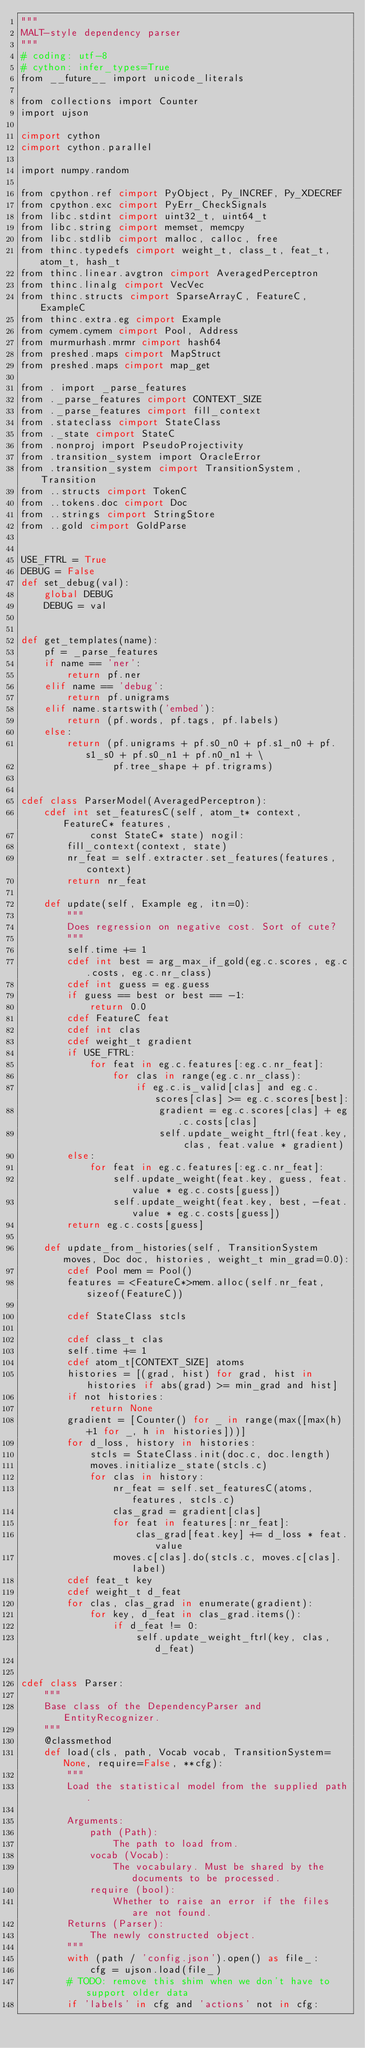<code> <loc_0><loc_0><loc_500><loc_500><_Cython_>"""
MALT-style dependency parser
"""
# coding: utf-8
# cython: infer_types=True
from __future__ import unicode_literals

from collections import Counter
import ujson

cimport cython
cimport cython.parallel

import numpy.random

from cpython.ref cimport PyObject, Py_INCREF, Py_XDECREF
from cpython.exc cimport PyErr_CheckSignals
from libc.stdint cimport uint32_t, uint64_t
from libc.string cimport memset, memcpy
from libc.stdlib cimport malloc, calloc, free
from thinc.typedefs cimport weight_t, class_t, feat_t, atom_t, hash_t
from thinc.linear.avgtron cimport AveragedPerceptron
from thinc.linalg cimport VecVec
from thinc.structs cimport SparseArrayC, FeatureC, ExampleC
from thinc.extra.eg cimport Example
from cymem.cymem cimport Pool, Address
from murmurhash.mrmr cimport hash64
from preshed.maps cimport MapStruct
from preshed.maps cimport map_get

from . import _parse_features
from ._parse_features cimport CONTEXT_SIZE
from ._parse_features cimport fill_context
from .stateclass cimport StateClass
from ._state cimport StateC
from .nonproj import PseudoProjectivity
from .transition_system import OracleError
from .transition_system cimport TransitionSystem, Transition
from ..structs cimport TokenC
from ..tokens.doc cimport Doc
from ..strings cimport StringStore
from ..gold cimport GoldParse


USE_FTRL = True
DEBUG = False
def set_debug(val):
    global DEBUG
    DEBUG = val


def get_templates(name):
    pf = _parse_features
    if name == 'ner':
        return pf.ner
    elif name == 'debug':
        return pf.unigrams
    elif name.startswith('embed'):
        return (pf.words, pf.tags, pf.labels)
    else:
        return (pf.unigrams + pf.s0_n0 + pf.s1_n0 + pf.s1_s0 + pf.s0_n1 + pf.n0_n1 + \
                pf.tree_shape + pf.trigrams)


cdef class ParserModel(AveragedPerceptron):
    cdef int set_featuresC(self, atom_t* context, FeatureC* features,
            const StateC* state) nogil:
        fill_context(context, state)
        nr_feat = self.extracter.set_features(features, context)
        return nr_feat

    def update(self, Example eg, itn=0):
        """
        Does regression on negative cost. Sort of cute?
        """
        self.time += 1
        cdef int best = arg_max_if_gold(eg.c.scores, eg.c.costs, eg.c.nr_class)
        cdef int guess = eg.guess
        if guess == best or best == -1:
            return 0.0
        cdef FeatureC feat
        cdef int clas
        cdef weight_t gradient
        if USE_FTRL:
            for feat in eg.c.features[:eg.c.nr_feat]:
                for clas in range(eg.c.nr_class):
                    if eg.c.is_valid[clas] and eg.c.scores[clas] >= eg.c.scores[best]:
                        gradient = eg.c.scores[clas] + eg.c.costs[clas]
                        self.update_weight_ftrl(feat.key, clas, feat.value * gradient)
        else:
            for feat in eg.c.features[:eg.c.nr_feat]:
                self.update_weight(feat.key, guess, feat.value * eg.c.costs[guess])
                self.update_weight(feat.key, best, -feat.value * eg.c.costs[guess])
        return eg.c.costs[guess]

    def update_from_histories(self, TransitionSystem moves, Doc doc, histories, weight_t min_grad=0.0):
        cdef Pool mem = Pool()
        features = <FeatureC*>mem.alloc(self.nr_feat, sizeof(FeatureC))

        cdef StateClass stcls

        cdef class_t clas
        self.time += 1
        cdef atom_t[CONTEXT_SIZE] atoms
        histories = [(grad, hist) for grad, hist in histories if abs(grad) >= min_grad and hist]
        if not histories:
            return None
        gradient = [Counter() for _ in range(max([max(h)+1 for _, h in histories]))]
        for d_loss, history in histories:
            stcls = StateClass.init(doc.c, doc.length)
            moves.initialize_state(stcls.c)
            for clas in history:
                nr_feat = self.set_featuresC(atoms, features, stcls.c)
                clas_grad = gradient[clas]
                for feat in features[:nr_feat]:
                    clas_grad[feat.key] += d_loss * feat.value
                moves.c[clas].do(stcls.c, moves.c[clas].label)
        cdef feat_t key
        cdef weight_t d_feat
        for clas, clas_grad in enumerate(gradient):
            for key, d_feat in clas_grad.items():
                if d_feat != 0:
                    self.update_weight_ftrl(key, clas, d_feat)


cdef class Parser:
    """
    Base class of the DependencyParser and EntityRecognizer.
    """
    @classmethod
    def load(cls, path, Vocab vocab, TransitionSystem=None, require=False, **cfg):
        """
        Load the statistical model from the supplied path.

        Arguments:
            path (Path):
                The path to load from.
            vocab (Vocab):
                The vocabulary. Must be shared by the documents to be processed.
            require (bool):
                Whether to raise an error if the files are not found.
        Returns (Parser):
            The newly constructed object.
        """
        with (path / 'config.json').open() as file_:
            cfg = ujson.load(file_)
        # TODO: remove this shim when we don't have to support older data
        if 'labels' in cfg and 'actions' not in cfg:</code> 